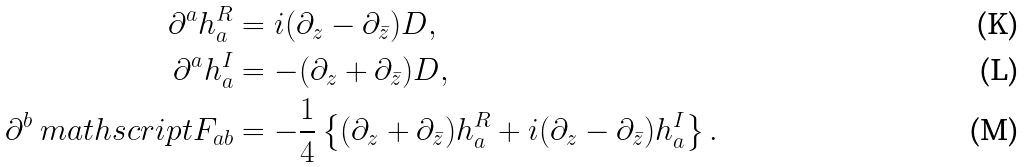Convert formula to latex. <formula><loc_0><loc_0><loc_500><loc_500>\partial ^ { a } h _ { a } ^ { R } & = i ( \partial _ { z } - \partial _ { \bar { z } } ) D , \\ \partial ^ { a } h _ { a } ^ { I } & = - ( \partial _ { z } + \partial _ { \bar { z } } ) D , \\ \partial ^ { b } \ m a t h s c r i p t F _ { a b } & = - \frac { 1 } { 4 } \left \{ ( \partial _ { z } + \partial _ { \bar { z } } ) h _ { a } ^ { R } + i ( \partial _ { z } - \partial _ { \bar { z } } ) h _ { a } ^ { I } \right \} .</formula> 